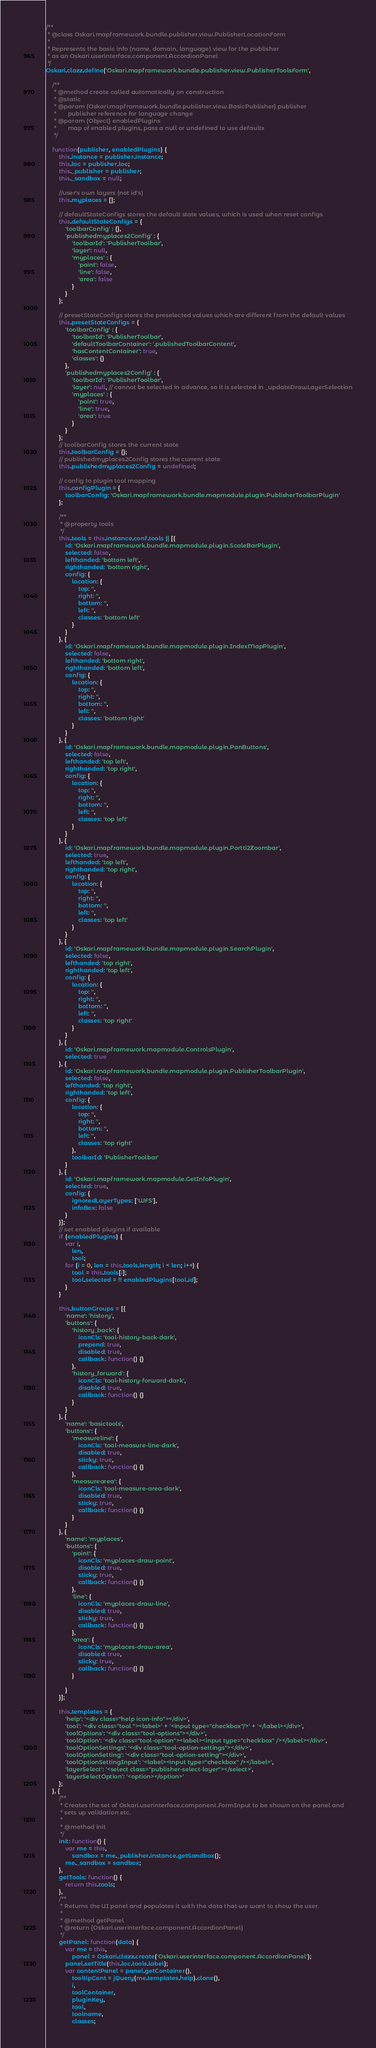<code> <loc_0><loc_0><loc_500><loc_500><_JavaScript_>/**
 * @class Oskari.mapframework.bundle.publisher.view.PublisherLocationForm
 *
 * Represents the basic info (name, domain, language) view for the publisher
 * as an Oskari.userinterface.component.AccordionPanel
 */
Oskari.clazz.define('Oskari.mapframework.bundle.publisher.view.PublisherToolsForm',

    /**
     * @method create called automatically on construction
     * @static
     * @param {Oskari.mapframework.bundle.publisher.view.BasicPublisher} publisher
     *       publisher reference for language change
     * @param {Object} enabledPlugins
     *       map of enabled plugins, pass a null or undefined to use defaults
     */

    function(publisher, enabledPlugins) {
        this.instance = publisher.instance;
        this.loc = publisher.loc;
        this._publisher = publisher;
        this._sandbox = null;

        //user's own layers (not id's)
        this.myplaces = [];

        // defaultStateConfigs stores the default state values, which is used when reset configs
        this.defaultStateConfigs = {
            'toolbarConfig' : {},
            'publishedmyplaces2Config' : {
                'toolbarId': 'PublisherToolbar',
                'layer': null,
                'myplaces' : {
                    'point': false,
                    'line': false,
                    'area': false
                }
            }
        };

        // presetStateConfigs stores the preselected values which are different from the default values
        this.presetStateConfigs = {
            'toolbarConfig' : {
                'toolbarId': 'PublisherToolbar',
                'defaultToolbarContainer': '.publishedToolbarContent',
                'hasContentContainer': true,
                'classes': {}
            },
            'publishedmyplaces2Config' : {
                'toolbarId': 'PublisherToolbar',
                'layer': null, // cannot be selected in advance, so it is selected in _updateDrawLayerSelection
                'myplaces' : {
                    'point': true, 
                    'line': true, 
                    'area': true
                }
            }
        };
        // toolbarConfig stores the current state
        this.toolbarConfig = {};
        // publishedmyplaces2Config stores the current state
        this.publishedmyplaces2Config = undefined;

        // config to plugin tool mapping
        this.configPlugin = {
            toolbarConfig: 'Oskari.mapframework.bundle.mapmodule.plugin.PublisherToolbarPlugin'
        };

        /**
         * @property tools
         */
        this.tools = this.instance.conf.tools || [{
            id: 'Oskari.mapframework.bundle.mapmodule.plugin.ScaleBarPlugin',
            selected: false,
            lefthanded: 'bottom left',
            righthanded: 'bottom right',
            config: {
                location: {
                    top: '',
                    right: '',
                    bottom: '',
                    left: '',
                    classes: 'bottom left'
                }
            }
        }, {
            id: 'Oskari.mapframework.bundle.mapmodule.plugin.IndexMapPlugin',
            selected: false,
            lefthanded: 'bottom right',
            righthanded: 'bottom left',
            config: {
                location: {
                    top: '',
                    right: '',
                    bottom: '',
                    left: '',
                    classes: 'bottom right'
                }
            }
        }, {
            id: 'Oskari.mapframework.bundle.mapmodule.plugin.PanButtons',
            selected: false,
            lefthanded: 'top left',
            righthanded: 'top right',
            config: {
                location: {
                    top: '',
                    right: '',
                    bottom: '',
                    left: '',
                    classes: 'top left'
                }
            }
        }, {
            id: 'Oskari.mapframework.bundle.mapmodule.plugin.Portti2Zoombar',
            selected: true,
            lefthanded: 'top left',
            righthanded: 'top right',
            config: {
                location: {
                    top: '',
                    right: '',
                    bottom: '',
                    left: '',
                    classes: 'top left'
                }
            }
        }, {
            id: 'Oskari.mapframework.bundle.mapmodule.plugin.SearchPlugin',
            selected: false,
            lefthanded: 'top right',
            righthanded: 'top left',
            config: {
                location: {
                    top: '',
                    right: '',
                    bottom: '',
                    left: '',
                    classes: 'top right'
                }
            }
        }, {
            id: 'Oskari.mapframework.mapmodule.ControlsPlugin',
            selected: true
        }, {
            id: 'Oskari.mapframework.bundle.mapmodule.plugin.PublisherToolbarPlugin',
            selected: false,
            lefthanded: 'top right',
            righthanded: 'top left',
            config: {
                location: {
                    top: '',
                    right: '',
                    bottom: '',
                    left: '',
                    classes: 'top right'
                },
                toolbarId: 'PublisherToolbar'
            }
        }, {
            id: 'Oskari.mapframework.mapmodule.GetInfoPlugin',
            selected: true,
            config: {
                ignoredLayerTypes: ['WFS'],
                infoBox: false
            }
        }];
        // set enabled plugins if available
        if (enabledPlugins) {
            var i,
                len,
                tool;
            for (i = 0, len = this.tools.length; i < len; i++) {
                tool = this.tools[i];
                tool.selected = !! enabledPlugins[tool.id];
            }
        }

        this.buttonGroups = [{
            'name': 'history',
            'buttons': {
                'history_back': {
                    iconCls: 'tool-history-back-dark',
                    prepend: true,
                    disabled: true,
                    callback: function() {}
                },
                'history_forward': {
                    iconCls: 'tool-history-forward-dark',
                    disabled: true,
                    callback: function() {}
                }
            }
        }, {
            'name': 'basictools',
            'buttons': {
                'measureline': {
                    iconCls: 'tool-measure-line-dark',
                    disabled: true,
                    sticky: true,
                    callback: function() {}
                },
                'measurearea': {
                    iconCls: 'tool-measure-area-dark',
                    disabled: true,
                    sticky: true,
                    callback: function() {}
                }
            }
        }, {
            'name': 'myplaces',
            'buttons': {
                'point': {
                    iconCls: 'myplaces-draw-point',
                    disabled: true,
                    sticky: true,
                    callback: function() {}
                },
                'line': {
                    iconCls: 'myplaces-draw-line',
                    disabled: true,
                    sticky: true,
                    callback: function() {}
                },
                'area': {
                    iconCls: 'myplaces-draw-area',
                    disabled: true,
                    sticky: true,
                    callback: function() {}
                }

            }
        }];

        this.templates = {
            'help': '<div class="help icon-info"></div>',
            'tool': '<div class="tool "><label>' + '<input type="checkbox"/>' + '</label></div>',
            'toolOptions': '<div class="tool-options"></div>',
            'toolOption': '<div class="tool-option"><label><input type="checkbox" /></label></div>',
            'toolOptionSettings': '<div class="tool-option-settings"></div>',
            'toolOptionSetting': '<div class="tool-option-setting"></div>',
            'toolOptionSettingInput': '<label><input type="checkbox" /></label>',
            'layerSelect': '<select class="publisher-select-layer"></select>',
            'layerSelectOption': '<option></option>'
        };
    }, {
        /**
         * Creates the set of Oskari.userinterface.component.FormInput to be shown on the panel and
         * sets up validation etc.
         *
         * @method init
         */
        init: function() {
            var me = this,
                sandbox = me._publisher.instance.getSandbox();
            me._sandbox = sandbox;
        },
        getTools: function() {
            return this.tools;
        },
        /**
         * Returns the UI panel and populates it with the data that we want to show the user.
         *
         * @method getPanel
         * @return {Oskari.userinterface.component.AccordionPanel}
         */
        getPanel: function(data) {
            var me = this,
                panel = Oskari.clazz.create('Oskari.userinterface.component.AccordionPanel');
            panel.setTitle(this.loc.tools.label);
            var contentPanel = panel.getContainer(),
                tooltipCont = jQuery(me.templates.help).clone(),
                i,
                toolContainer,
                pluginKey,
                tool,
                toolname,
                classes;
</code> 